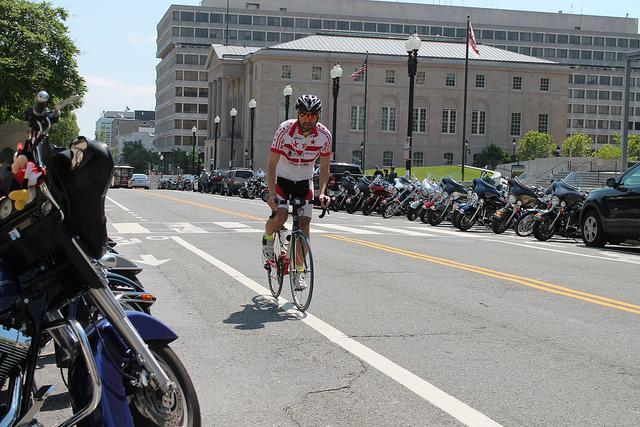How many flags are in the picture?
Give a very brief answer. 1. How many motorcycles can be seen?
Give a very brief answer. 3. 